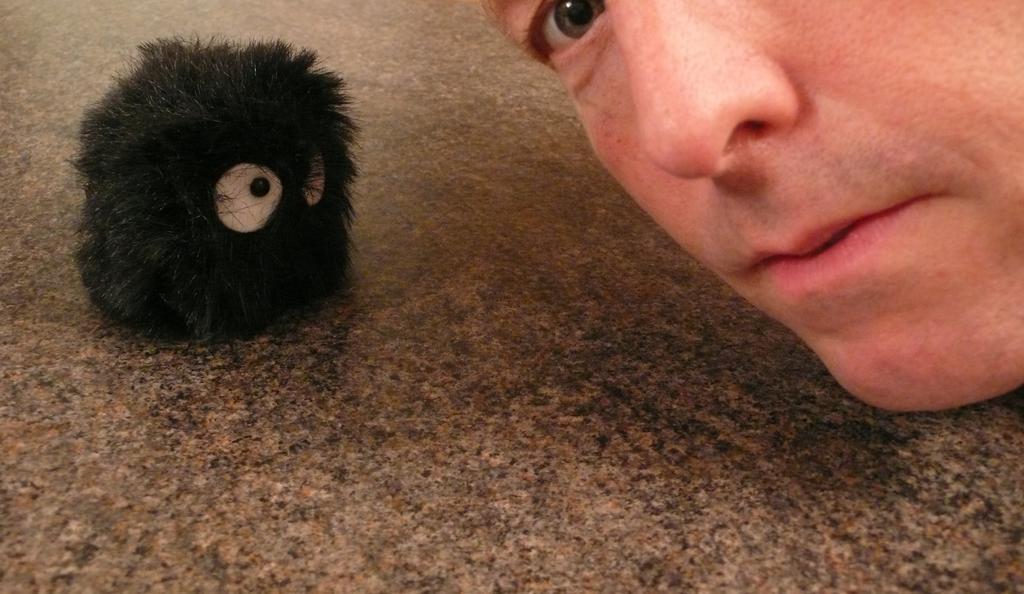In one or two sentences, can you explain what this image depicts? On the left side, we see a black color toy. On the right side, we see the face of the man. We can only see the eye, nose and the mouth of the man. At the bottom of the picture, we see the floor. 